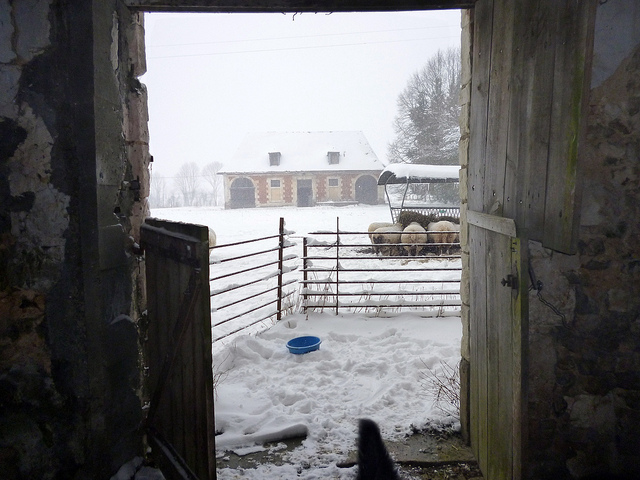<image>What species of giraffe is in the photo? There is no giraffe in the image. What species of giraffe is in the photo? I don't know the species of the giraffe in the photo. It can be reticulated or unknown. 